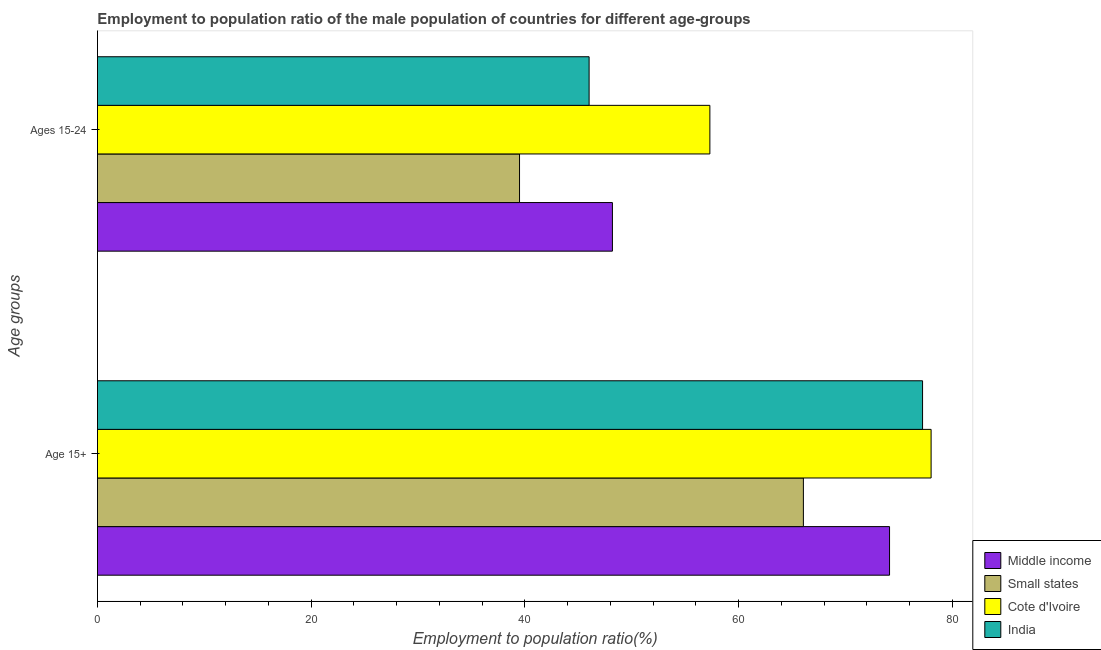How many groups of bars are there?
Offer a very short reply. 2. How many bars are there on the 2nd tick from the top?
Make the answer very short. 4. How many bars are there on the 2nd tick from the bottom?
Offer a terse response. 4. What is the label of the 2nd group of bars from the top?
Offer a very short reply. Age 15+. What is the employment to population ratio(age 15-24) in Middle income?
Make the answer very short. 48.18. Across all countries, what is the maximum employment to population ratio(age 15-24)?
Keep it short and to the point. 57.3. Across all countries, what is the minimum employment to population ratio(age 15-24)?
Your response must be concise. 39.49. In which country was the employment to population ratio(age 15+) maximum?
Provide a short and direct response. Cote d'Ivoire. In which country was the employment to population ratio(age 15-24) minimum?
Give a very brief answer. Small states. What is the total employment to population ratio(age 15+) in the graph?
Give a very brief answer. 295.36. What is the difference between the employment to population ratio(age 15+) in Middle income and that in Cote d'Ivoire?
Keep it short and to the point. -3.89. What is the difference between the employment to population ratio(age 15-24) in Middle income and the employment to population ratio(age 15+) in Cote d'Ivoire?
Keep it short and to the point. -29.82. What is the average employment to population ratio(age 15+) per country?
Your answer should be compact. 73.84. What is the difference between the employment to population ratio(age 15+) and employment to population ratio(age 15-24) in Middle income?
Keep it short and to the point. 25.93. What is the ratio of the employment to population ratio(age 15-24) in India to that in Cote d'Ivoire?
Your answer should be compact. 0.8. Is the employment to population ratio(age 15+) in India less than that in Small states?
Give a very brief answer. No. In how many countries, is the employment to population ratio(age 15-24) greater than the average employment to population ratio(age 15-24) taken over all countries?
Make the answer very short. 2. What does the 3rd bar from the bottom in Age 15+ represents?
Your answer should be very brief. Cote d'Ivoire. Are all the bars in the graph horizontal?
Make the answer very short. Yes. How many countries are there in the graph?
Offer a very short reply. 4. What is the difference between two consecutive major ticks on the X-axis?
Give a very brief answer. 20. Does the graph contain any zero values?
Offer a terse response. No. How are the legend labels stacked?
Keep it short and to the point. Vertical. What is the title of the graph?
Give a very brief answer. Employment to population ratio of the male population of countries for different age-groups. What is the label or title of the Y-axis?
Provide a succinct answer. Age groups. What is the Employment to population ratio(%) of Middle income in Age 15+?
Offer a very short reply. 74.11. What is the Employment to population ratio(%) of Small states in Age 15+?
Keep it short and to the point. 66.05. What is the Employment to population ratio(%) in Cote d'Ivoire in Age 15+?
Your answer should be compact. 78. What is the Employment to population ratio(%) of India in Age 15+?
Ensure brevity in your answer.  77.2. What is the Employment to population ratio(%) of Middle income in Ages 15-24?
Provide a short and direct response. 48.18. What is the Employment to population ratio(%) of Small states in Ages 15-24?
Provide a short and direct response. 39.49. What is the Employment to population ratio(%) in Cote d'Ivoire in Ages 15-24?
Your answer should be very brief. 57.3. Across all Age groups, what is the maximum Employment to population ratio(%) in Middle income?
Your response must be concise. 74.11. Across all Age groups, what is the maximum Employment to population ratio(%) of Small states?
Keep it short and to the point. 66.05. Across all Age groups, what is the maximum Employment to population ratio(%) in India?
Provide a succinct answer. 77.2. Across all Age groups, what is the minimum Employment to population ratio(%) in Middle income?
Keep it short and to the point. 48.18. Across all Age groups, what is the minimum Employment to population ratio(%) in Small states?
Offer a very short reply. 39.49. Across all Age groups, what is the minimum Employment to population ratio(%) of Cote d'Ivoire?
Offer a terse response. 57.3. What is the total Employment to population ratio(%) in Middle income in the graph?
Offer a terse response. 122.29. What is the total Employment to population ratio(%) in Small states in the graph?
Keep it short and to the point. 105.54. What is the total Employment to population ratio(%) of Cote d'Ivoire in the graph?
Keep it short and to the point. 135.3. What is the total Employment to population ratio(%) of India in the graph?
Offer a very short reply. 123.2. What is the difference between the Employment to population ratio(%) in Middle income in Age 15+ and that in Ages 15-24?
Offer a terse response. 25.93. What is the difference between the Employment to population ratio(%) in Small states in Age 15+ and that in Ages 15-24?
Your response must be concise. 26.56. What is the difference between the Employment to population ratio(%) in Cote d'Ivoire in Age 15+ and that in Ages 15-24?
Your response must be concise. 20.7. What is the difference between the Employment to population ratio(%) of India in Age 15+ and that in Ages 15-24?
Make the answer very short. 31.2. What is the difference between the Employment to population ratio(%) in Middle income in Age 15+ and the Employment to population ratio(%) in Small states in Ages 15-24?
Your answer should be very brief. 34.62. What is the difference between the Employment to population ratio(%) in Middle income in Age 15+ and the Employment to population ratio(%) in Cote d'Ivoire in Ages 15-24?
Offer a very short reply. 16.81. What is the difference between the Employment to population ratio(%) in Middle income in Age 15+ and the Employment to population ratio(%) in India in Ages 15-24?
Your answer should be compact. 28.11. What is the difference between the Employment to population ratio(%) in Small states in Age 15+ and the Employment to population ratio(%) in Cote d'Ivoire in Ages 15-24?
Ensure brevity in your answer.  8.75. What is the difference between the Employment to population ratio(%) of Small states in Age 15+ and the Employment to population ratio(%) of India in Ages 15-24?
Your response must be concise. 20.05. What is the difference between the Employment to population ratio(%) in Cote d'Ivoire in Age 15+ and the Employment to population ratio(%) in India in Ages 15-24?
Keep it short and to the point. 32. What is the average Employment to population ratio(%) of Middle income per Age groups?
Ensure brevity in your answer.  61.15. What is the average Employment to population ratio(%) in Small states per Age groups?
Make the answer very short. 52.77. What is the average Employment to population ratio(%) of Cote d'Ivoire per Age groups?
Provide a short and direct response. 67.65. What is the average Employment to population ratio(%) of India per Age groups?
Your answer should be compact. 61.6. What is the difference between the Employment to population ratio(%) of Middle income and Employment to population ratio(%) of Small states in Age 15+?
Your answer should be very brief. 8.06. What is the difference between the Employment to population ratio(%) of Middle income and Employment to population ratio(%) of Cote d'Ivoire in Age 15+?
Your answer should be very brief. -3.89. What is the difference between the Employment to population ratio(%) in Middle income and Employment to population ratio(%) in India in Age 15+?
Keep it short and to the point. -3.09. What is the difference between the Employment to population ratio(%) in Small states and Employment to population ratio(%) in Cote d'Ivoire in Age 15+?
Ensure brevity in your answer.  -11.95. What is the difference between the Employment to population ratio(%) in Small states and Employment to population ratio(%) in India in Age 15+?
Offer a terse response. -11.15. What is the difference between the Employment to population ratio(%) of Middle income and Employment to population ratio(%) of Small states in Ages 15-24?
Offer a terse response. 8.69. What is the difference between the Employment to population ratio(%) of Middle income and Employment to population ratio(%) of Cote d'Ivoire in Ages 15-24?
Your answer should be very brief. -9.12. What is the difference between the Employment to population ratio(%) of Middle income and Employment to population ratio(%) of India in Ages 15-24?
Your answer should be very brief. 2.18. What is the difference between the Employment to population ratio(%) in Small states and Employment to population ratio(%) in Cote d'Ivoire in Ages 15-24?
Offer a terse response. -17.81. What is the difference between the Employment to population ratio(%) of Small states and Employment to population ratio(%) of India in Ages 15-24?
Provide a succinct answer. -6.51. What is the ratio of the Employment to population ratio(%) in Middle income in Age 15+ to that in Ages 15-24?
Provide a short and direct response. 1.54. What is the ratio of the Employment to population ratio(%) in Small states in Age 15+ to that in Ages 15-24?
Provide a short and direct response. 1.67. What is the ratio of the Employment to population ratio(%) in Cote d'Ivoire in Age 15+ to that in Ages 15-24?
Provide a short and direct response. 1.36. What is the ratio of the Employment to population ratio(%) in India in Age 15+ to that in Ages 15-24?
Offer a very short reply. 1.68. What is the difference between the highest and the second highest Employment to population ratio(%) in Middle income?
Your answer should be very brief. 25.93. What is the difference between the highest and the second highest Employment to population ratio(%) in Small states?
Provide a succinct answer. 26.56. What is the difference between the highest and the second highest Employment to population ratio(%) in Cote d'Ivoire?
Make the answer very short. 20.7. What is the difference between the highest and the second highest Employment to population ratio(%) in India?
Offer a very short reply. 31.2. What is the difference between the highest and the lowest Employment to population ratio(%) of Middle income?
Make the answer very short. 25.93. What is the difference between the highest and the lowest Employment to population ratio(%) of Small states?
Keep it short and to the point. 26.56. What is the difference between the highest and the lowest Employment to population ratio(%) of Cote d'Ivoire?
Offer a very short reply. 20.7. What is the difference between the highest and the lowest Employment to population ratio(%) in India?
Your answer should be compact. 31.2. 